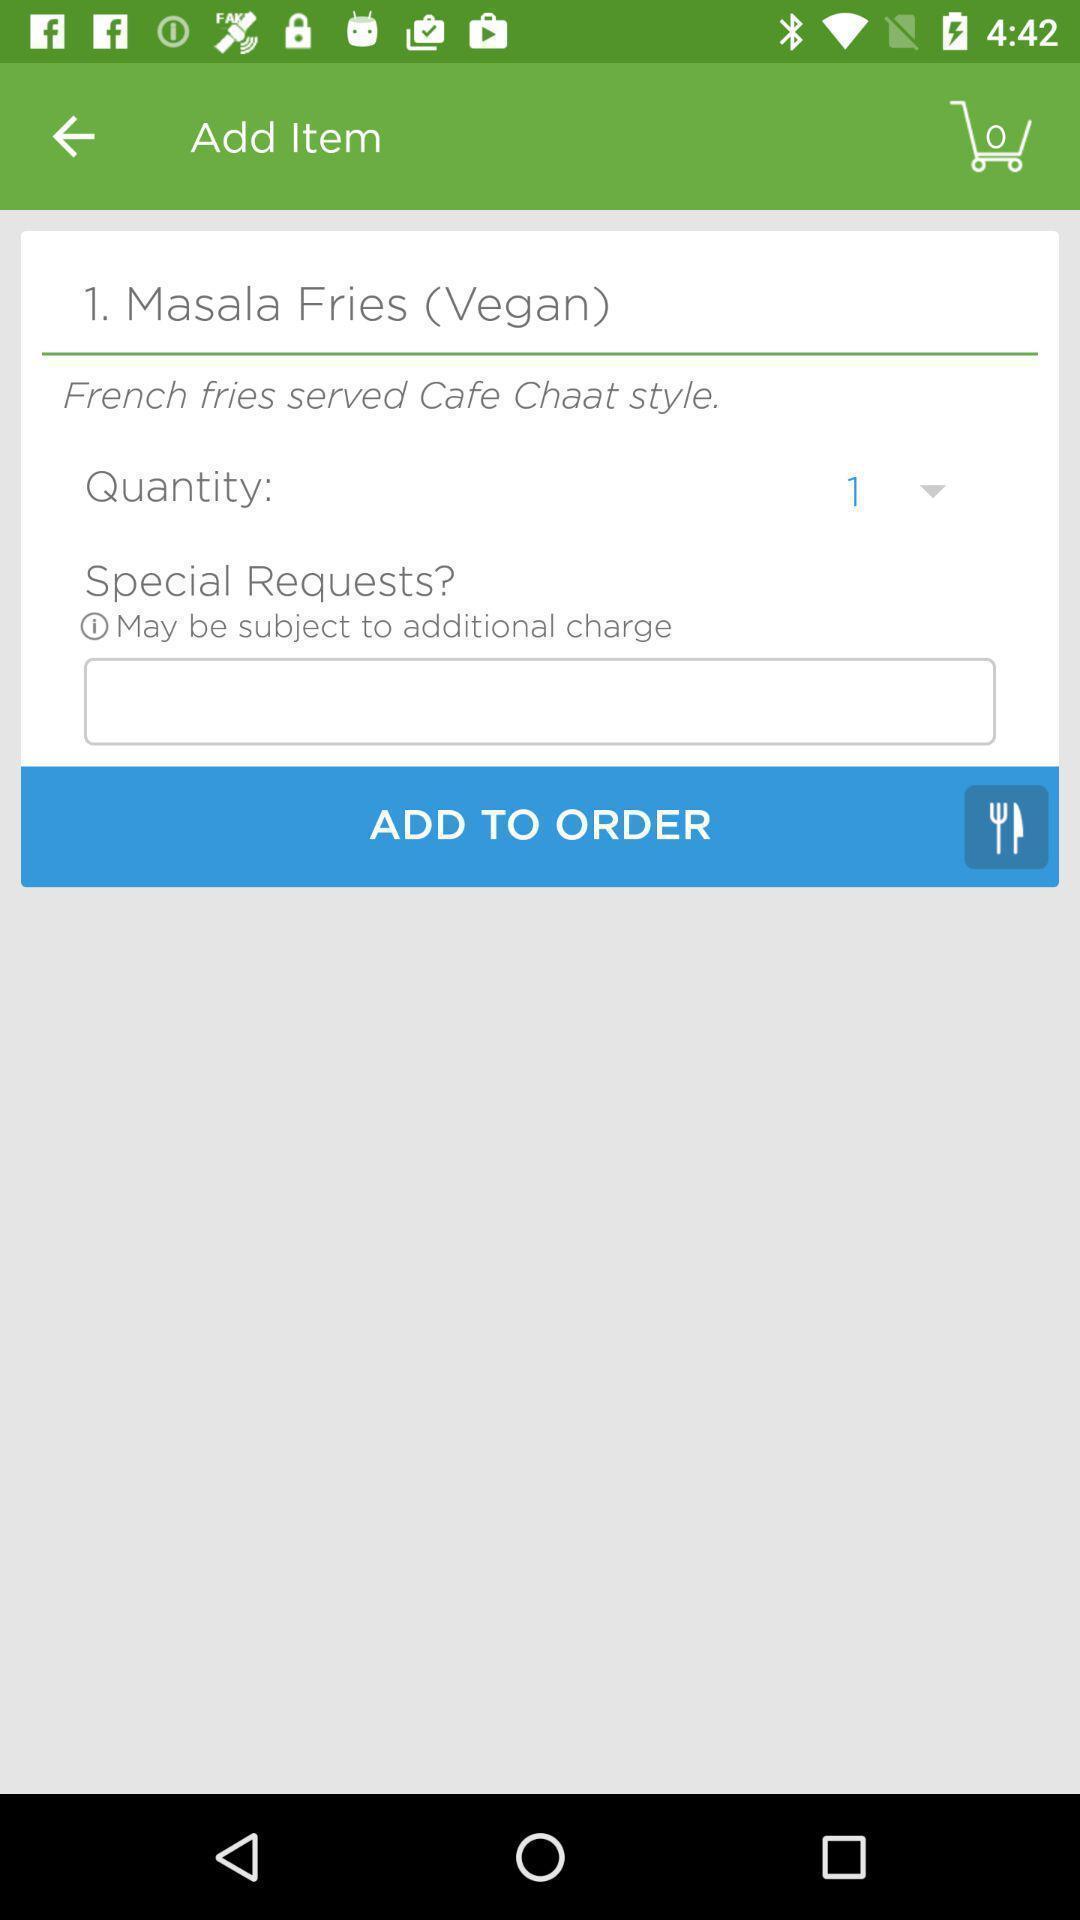Provide a detailed account of this screenshot. Screen showing add to order page of a food app. 